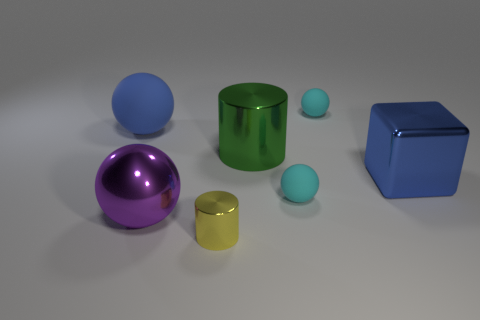Subtract all big purple metallic balls. How many balls are left? 3 Add 3 green metal things. How many objects exist? 10 Subtract all purple spheres. How many spheres are left? 3 Subtract 1 spheres. How many spheres are left? 3 Subtract all blue balls. Subtract all gray blocks. How many balls are left? 3 Subtract all balls. How many objects are left? 3 Add 5 large metal objects. How many large metal objects are left? 8 Add 3 tiny cubes. How many tiny cubes exist? 3 Subtract 0 gray cylinders. How many objects are left? 7 Subtract all tiny gray metallic spheres. Subtract all tiny yellow things. How many objects are left? 6 